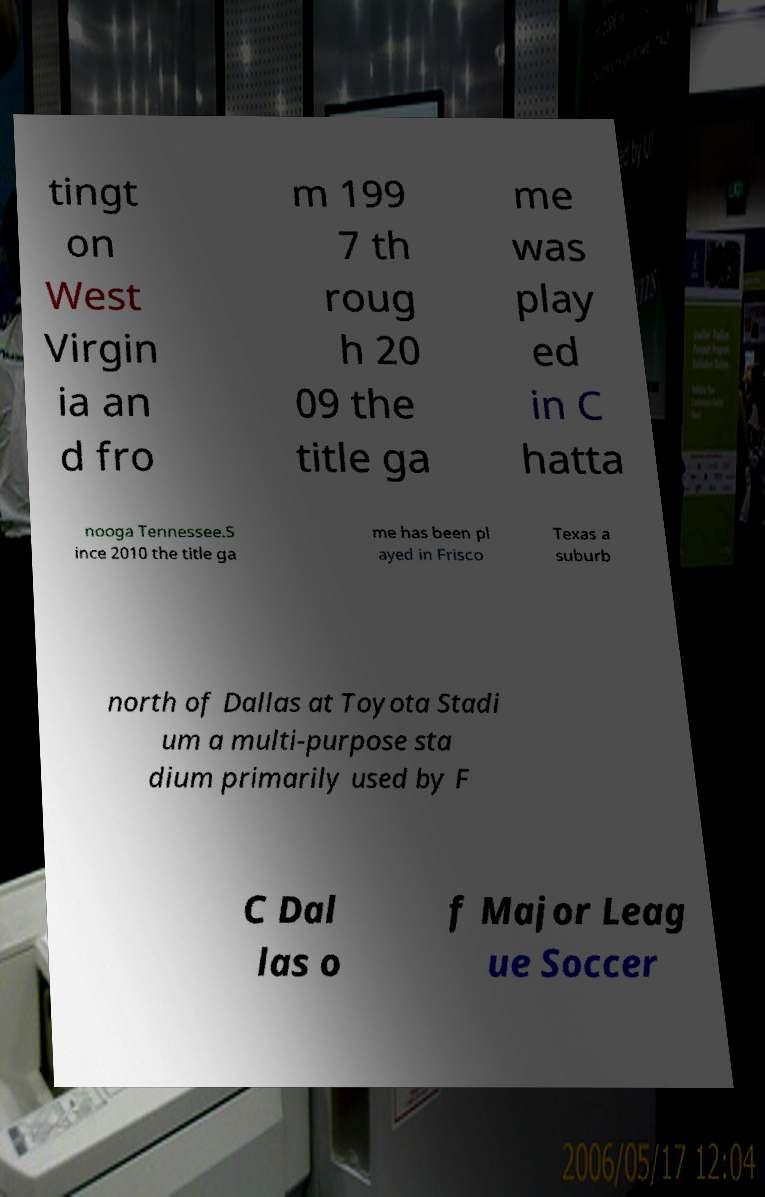Please identify and transcribe the text found in this image. tingt on West Virgin ia an d fro m 199 7 th roug h 20 09 the title ga me was play ed in C hatta nooga Tennessee.S ince 2010 the title ga me has been pl ayed in Frisco Texas a suburb north of Dallas at Toyota Stadi um a multi-purpose sta dium primarily used by F C Dal las o f Major Leag ue Soccer 